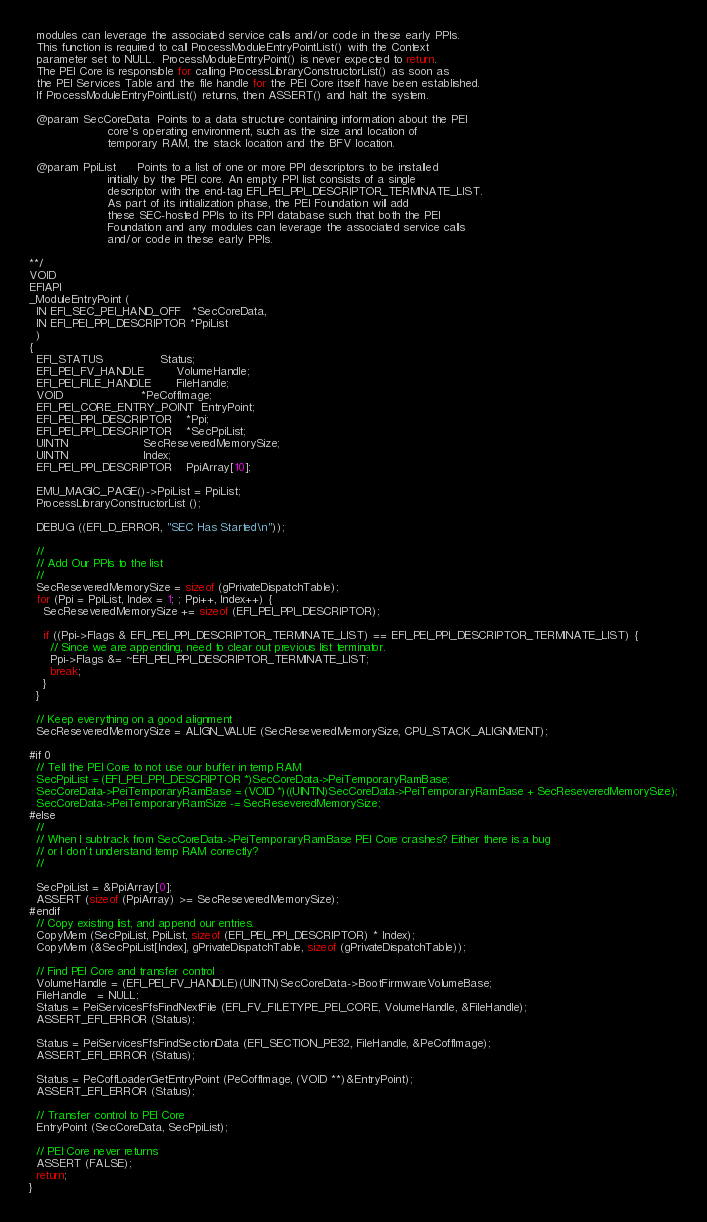<code> <loc_0><loc_0><loc_500><loc_500><_C_>  modules can leverage the associated service calls and/or code in these early PPIs.
  This function is required to call ProcessModuleEntryPointList() with the Context
  parameter set to NULL.  ProcessModuleEntryPoint() is never expected to return.
  The PEI Core is responsible for calling ProcessLibraryConstructorList() as soon as
  the PEI Services Table and the file handle for the PEI Core itself have been established.
  If ProcessModuleEntryPointList() returns, then ASSERT() and halt the system.

  @param SecCoreData  Points to a data structure containing information about the PEI
                      core's operating environment, such as the size and location of
                      temporary RAM, the stack location and the BFV location.

  @param PpiList      Points to a list of one or more PPI descriptors to be installed
                      initially by the PEI core. An empty PPI list consists of a single
                      descriptor with the end-tag EFI_PEI_PPI_DESCRIPTOR_TERMINATE_LIST.
                      As part of its initialization phase, the PEI Foundation will add
                      these SEC-hosted PPIs to its PPI database such that both the PEI
                      Foundation and any modules can leverage the associated service calls
                      and/or code in these early PPIs.

**/
VOID
EFIAPI
_ModuleEntryPoint (
  IN EFI_SEC_PEI_HAND_OFF   *SecCoreData,
  IN EFI_PEI_PPI_DESCRIPTOR *PpiList
  )
{
  EFI_STATUS                Status;
  EFI_PEI_FV_HANDLE         VolumeHandle;
  EFI_PEI_FILE_HANDLE       FileHandle;
  VOID                      *PeCoffImage;
  EFI_PEI_CORE_ENTRY_POINT  EntryPoint;
  EFI_PEI_PPI_DESCRIPTOR    *Ppi;
  EFI_PEI_PPI_DESCRIPTOR    *SecPpiList;
  UINTN                     SecReseveredMemorySize;
  UINTN                     Index;
  EFI_PEI_PPI_DESCRIPTOR    PpiArray[10];

  EMU_MAGIC_PAGE()->PpiList = PpiList;
  ProcessLibraryConstructorList ();

  DEBUG ((EFI_D_ERROR, "SEC Has Started\n"));

  //
  // Add Our PPIs to the list
  //
  SecReseveredMemorySize = sizeof (gPrivateDispatchTable);
  for (Ppi = PpiList, Index = 1; ; Ppi++, Index++) {
    SecReseveredMemorySize += sizeof (EFI_PEI_PPI_DESCRIPTOR);

    if ((Ppi->Flags & EFI_PEI_PPI_DESCRIPTOR_TERMINATE_LIST) == EFI_PEI_PPI_DESCRIPTOR_TERMINATE_LIST) {
      // Since we are appending, need to clear out previous list terminator.
      Ppi->Flags &= ~EFI_PEI_PPI_DESCRIPTOR_TERMINATE_LIST;
      break;
    }
  }

  // Keep everything on a good alignment
  SecReseveredMemorySize = ALIGN_VALUE (SecReseveredMemorySize, CPU_STACK_ALIGNMENT);

#if 0
  // Tell the PEI Core to not use our buffer in temp RAM
  SecPpiList = (EFI_PEI_PPI_DESCRIPTOR *)SecCoreData->PeiTemporaryRamBase;
  SecCoreData->PeiTemporaryRamBase = (VOID *)((UINTN)SecCoreData->PeiTemporaryRamBase + SecReseveredMemorySize);
  SecCoreData->PeiTemporaryRamSize -= SecReseveredMemorySize;
#else
  //
  // When I subtrack from SecCoreData->PeiTemporaryRamBase PEI Core crashes? Either there is a bug
  // or I don't understand temp RAM correctly?
  //

  SecPpiList = &PpiArray[0];
  ASSERT (sizeof (PpiArray) >= SecReseveredMemorySize);
#endif
  // Copy existing list, and append our entries.
  CopyMem (SecPpiList, PpiList, sizeof (EFI_PEI_PPI_DESCRIPTOR) * Index);
  CopyMem (&SecPpiList[Index], gPrivateDispatchTable, sizeof (gPrivateDispatchTable));

  // Find PEI Core and transfer control
  VolumeHandle = (EFI_PEI_FV_HANDLE)(UINTN)SecCoreData->BootFirmwareVolumeBase;
  FileHandle   = NULL;
  Status = PeiServicesFfsFindNextFile (EFI_FV_FILETYPE_PEI_CORE, VolumeHandle, &FileHandle);
  ASSERT_EFI_ERROR (Status);

  Status = PeiServicesFfsFindSectionData (EFI_SECTION_PE32, FileHandle, &PeCoffImage);
  ASSERT_EFI_ERROR (Status);

  Status = PeCoffLoaderGetEntryPoint (PeCoffImage, (VOID **)&EntryPoint);
  ASSERT_EFI_ERROR (Status);

  // Transfer control to PEI Core
  EntryPoint (SecCoreData, SecPpiList);

  // PEI Core never returns
  ASSERT (FALSE);
  return;
}


</code> 